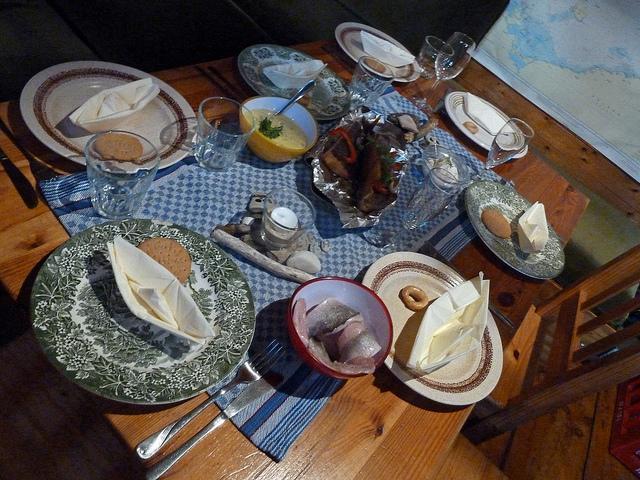How many bowls are there?
Give a very brief answer. 2. How many cups are there?
Give a very brief answer. 3. How many black and white dogs are in the image?
Give a very brief answer. 0. 